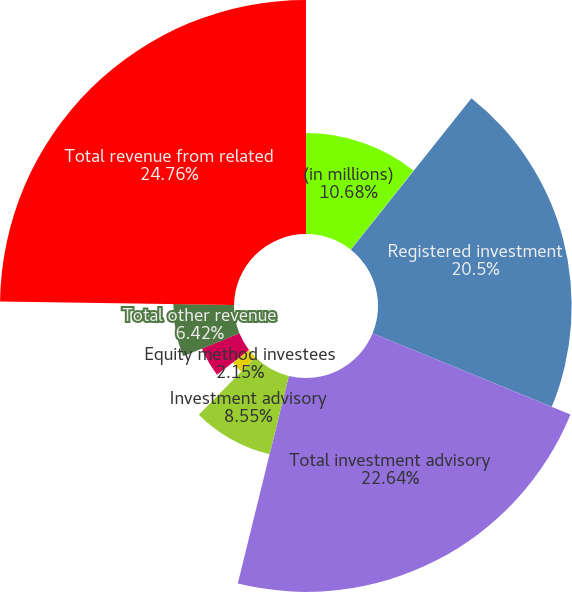<chart> <loc_0><loc_0><loc_500><loc_500><pie_chart><fcel>(in millions)<fcel>PNC and affiliates<fcel>Registered investment<fcel>Total investment advisory<fcel>Investment advisory<fcel>Equity method investees<fcel>Total BlackRock Solutions and<fcel>Total other revenue<fcel>Total revenue from related<nl><fcel>10.68%<fcel>0.02%<fcel>20.5%<fcel>22.64%<fcel>8.55%<fcel>2.15%<fcel>4.28%<fcel>6.42%<fcel>24.77%<nl></chart> 